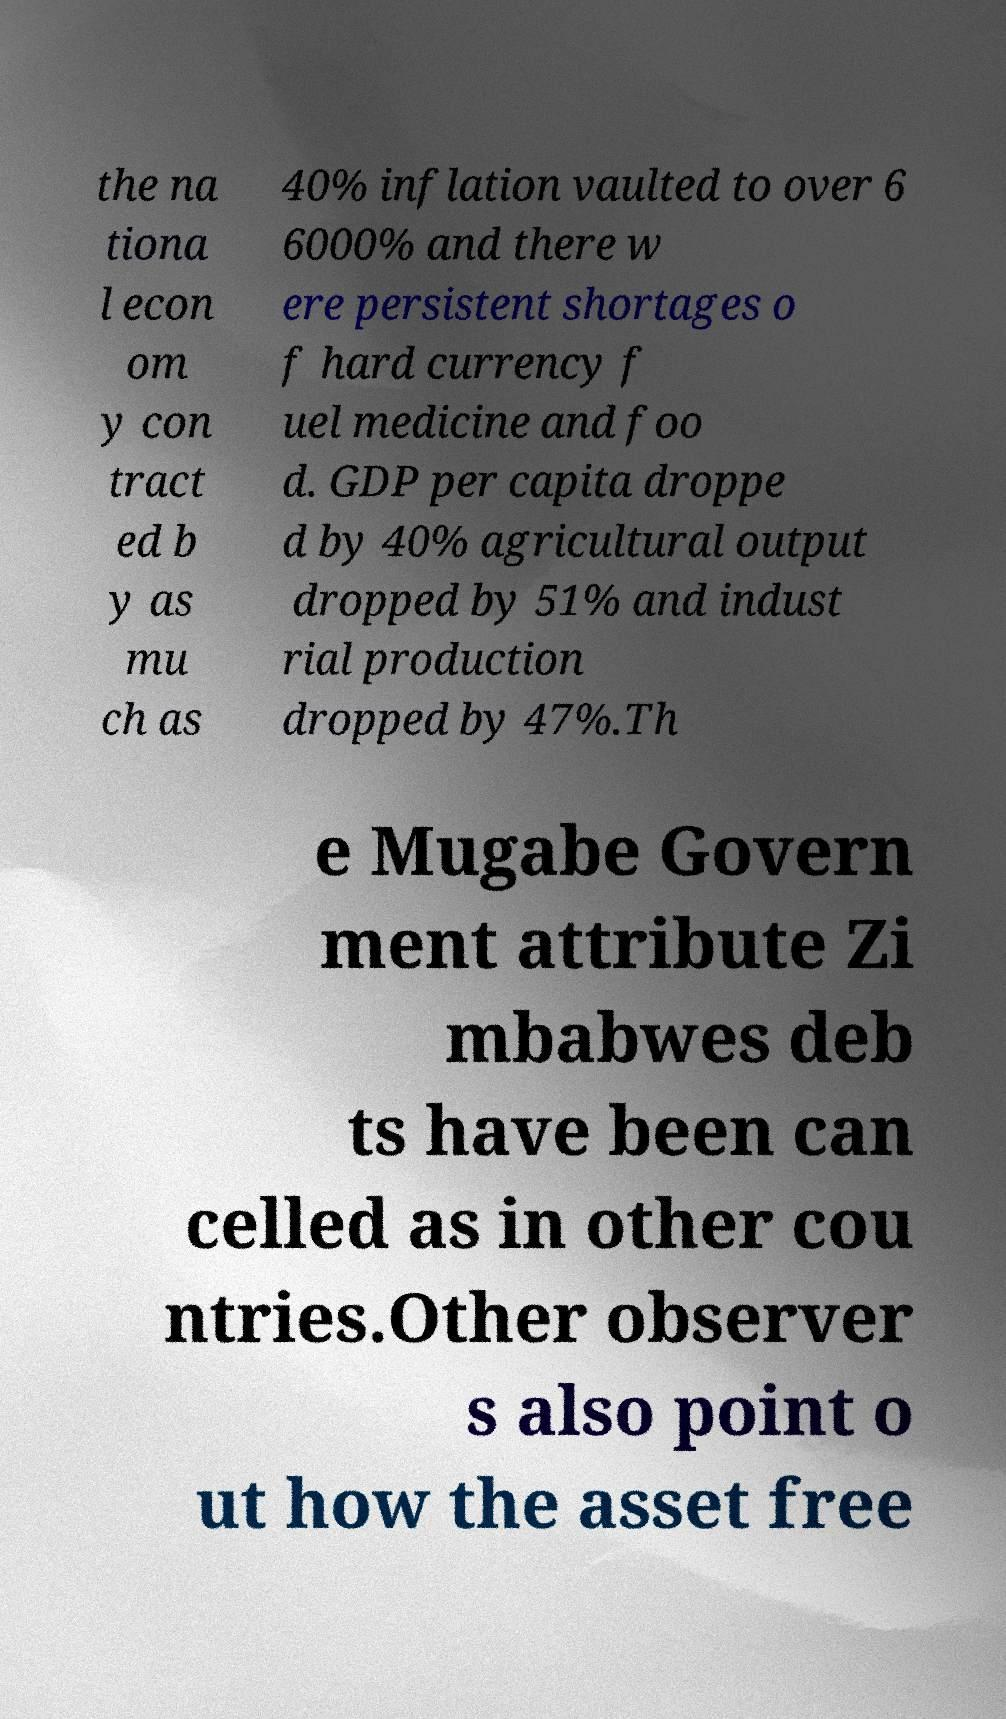Could you assist in decoding the text presented in this image and type it out clearly? the na tiona l econ om y con tract ed b y as mu ch as 40% inflation vaulted to over 6 6000% and there w ere persistent shortages o f hard currency f uel medicine and foo d. GDP per capita droppe d by 40% agricultural output dropped by 51% and indust rial production dropped by 47%.Th e Mugabe Govern ment attribute Zi mbabwes deb ts have been can celled as in other cou ntries.Other observer s also point o ut how the asset free 